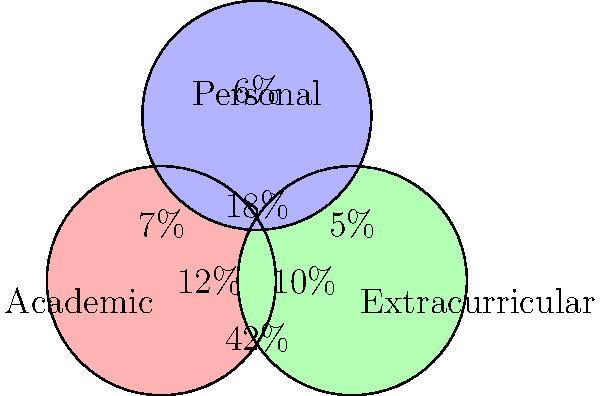The Venn diagram above represents the overlapping qualities of successful applicants across different programs. The percentages indicate the proportion of applicants with each combination of qualities. What percentage of successful applicants possess all three qualities: Academic, Extracurricular, and Personal? To solve this problem, we need to analyze the Venn diagram and identify the region where all three circles overlap. This region represents applicants who possess all three qualities: Academic, Extracurricular, and Personal.

Step 1: Locate the center region of the Venn diagram where all three circles intersect.
Step 2: Identify the percentage associated with this region.
Step 3: The percentage in the center region is 18%.

Therefore, 18% of successful applicants possess all three qualities: Academic, Extracurricular, and Personal.

This information is valuable for understanding holistic admissions practices, as it shows that a significant portion of successful applicants demonstrate strengths across multiple areas, rather than excelling in just one dimension.
Answer: 18% 